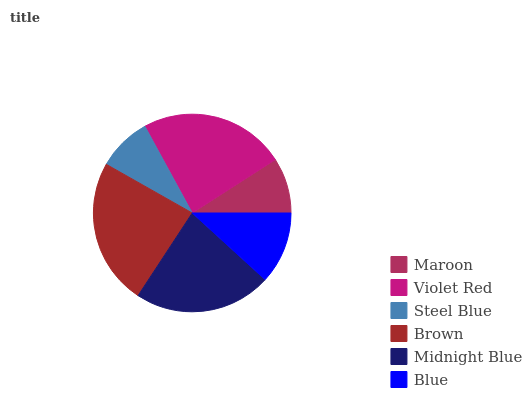Is Steel Blue the minimum?
Answer yes or no. Yes. Is Brown the maximum?
Answer yes or no. Yes. Is Violet Red the minimum?
Answer yes or no. No. Is Violet Red the maximum?
Answer yes or no. No. Is Violet Red greater than Maroon?
Answer yes or no. Yes. Is Maroon less than Violet Red?
Answer yes or no. Yes. Is Maroon greater than Violet Red?
Answer yes or no. No. Is Violet Red less than Maroon?
Answer yes or no. No. Is Midnight Blue the high median?
Answer yes or no. Yes. Is Blue the low median?
Answer yes or no. Yes. Is Blue the high median?
Answer yes or no. No. Is Violet Red the low median?
Answer yes or no. No. 